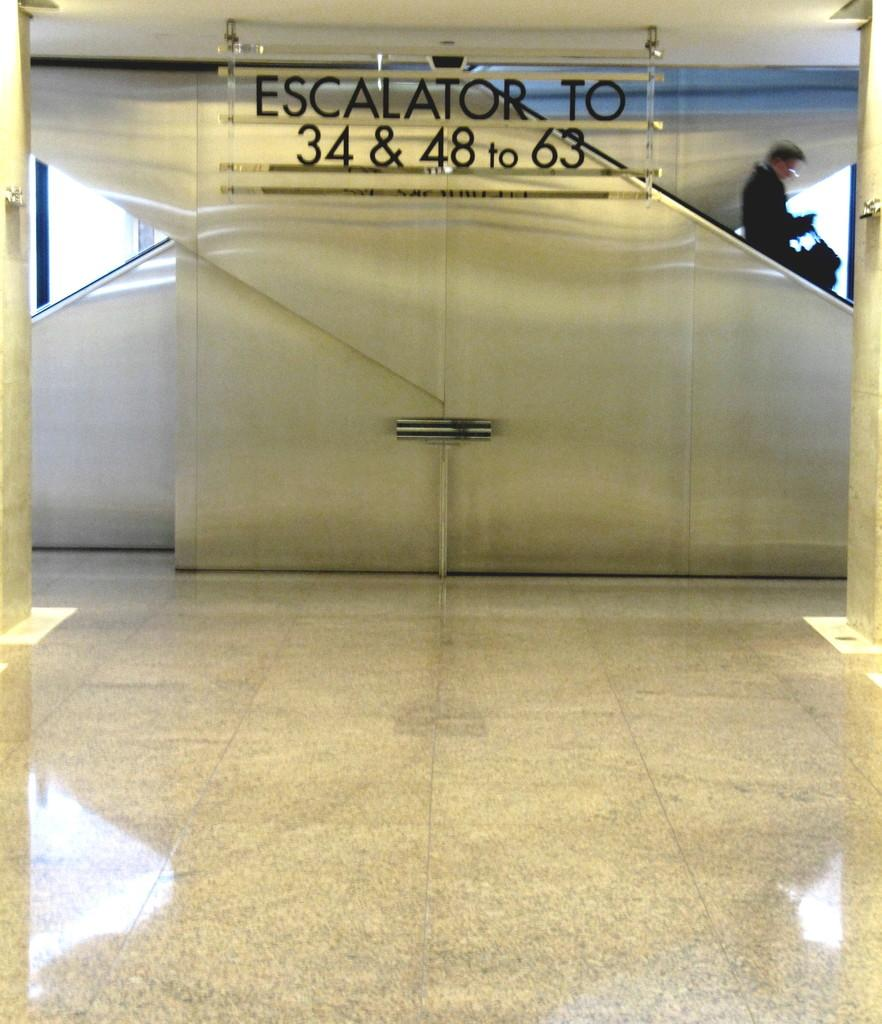What type of structure is visible in the image? There is a staircase in the image. What else can be seen in the image besides the staircase? Text and lights are visible in the image. Is there a person present in the image? Yes, there is a person in the image. What is the person holding in their hand? The person is holding a bag in their hand. Can you describe the setting of the image? The image may have been taken in a building. What color is the steel used in the construction of the staircase in the image? There is no mention of steel in the image, and the color of the staircase is not specified. 